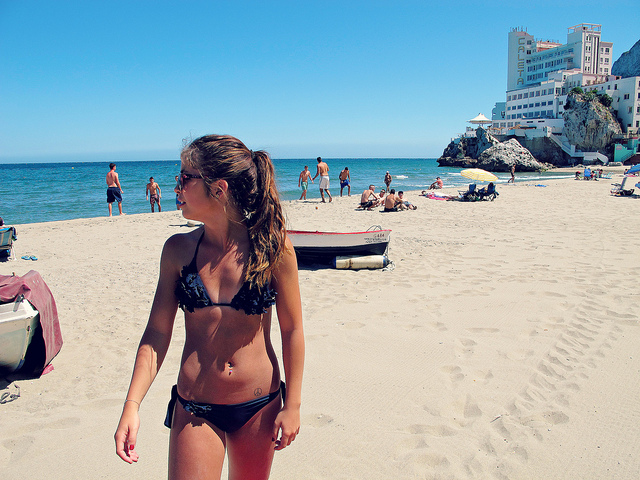Identify the text contained in this image. CALETA 